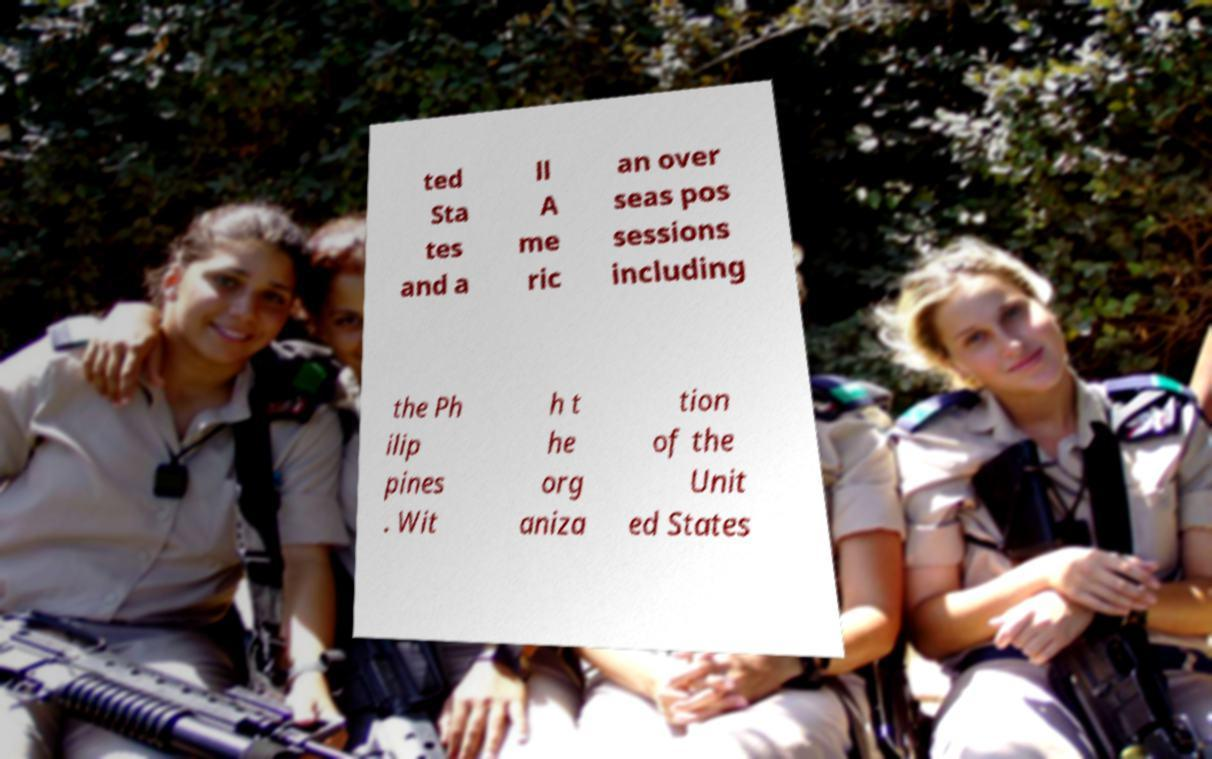What messages or text are displayed in this image? I need them in a readable, typed format. ted Sta tes and a ll A me ric an over seas pos sessions including the Ph ilip pines . Wit h t he org aniza tion of the Unit ed States 